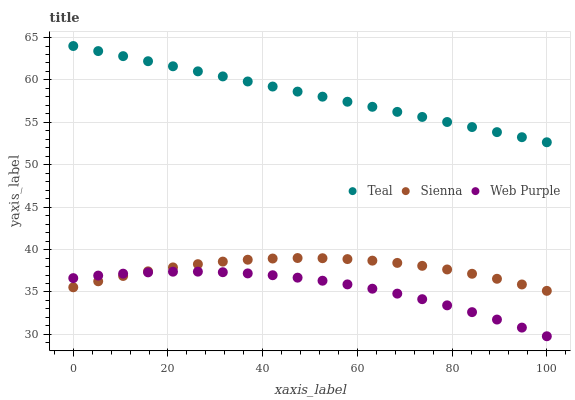Does Web Purple have the minimum area under the curve?
Answer yes or no. Yes. Does Teal have the maximum area under the curve?
Answer yes or no. Yes. Does Teal have the minimum area under the curve?
Answer yes or no. No. Does Web Purple have the maximum area under the curve?
Answer yes or no. No. Is Teal the smoothest?
Answer yes or no. Yes. Is Sienna the roughest?
Answer yes or no. Yes. Is Web Purple the smoothest?
Answer yes or no. No. Is Web Purple the roughest?
Answer yes or no. No. Does Web Purple have the lowest value?
Answer yes or no. Yes. Does Teal have the lowest value?
Answer yes or no. No. Does Teal have the highest value?
Answer yes or no. Yes. Does Web Purple have the highest value?
Answer yes or no. No. Is Sienna less than Teal?
Answer yes or no. Yes. Is Teal greater than Web Purple?
Answer yes or no. Yes. Does Web Purple intersect Sienna?
Answer yes or no. Yes. Is Web Purple less than Sienna?
Answer yes or no. No. Is Web Purple greater than Sienna?
Answer yes or no. No. Does Sienna intersect Teal?
Answer yes or no. No. 